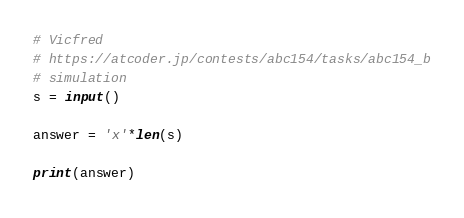Convert code to text. <code><loc_0><loc_0><loc_500><loc_500><_Python_># Vicfred
# https://atcoder.jp/contests/abc154/tasks/abc154_b
# simulation
s = input()

answer = 'x'*len(s)

print(answer)

</code> 